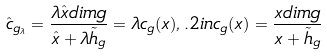Convert formula to latex. <formula><loc_0><loc_0><loc_500><loc_500>\hat { c } _ { g _ { \lambda } } = \frac { \lambda \hat { x } d i m g } { \hat { x } + \lambda \tilde { h } _ { g } } = \lambda c _ { g } ( x ) , . 2 i n c _ { g } ( x ) = \frac { x d i m g } { x + \tilde { h } _ { g } }</formula> 